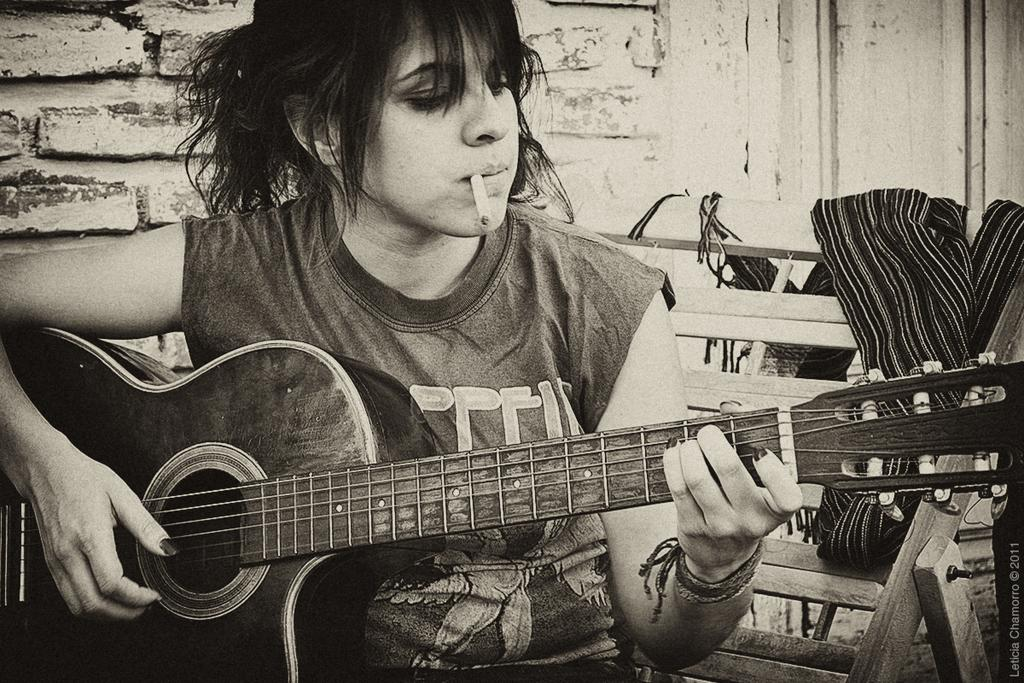Who is the main subject in the image? There is a woman in the image. What is the woman doing in the image? The woman is sitting on a wooden chair and playing a guitar. What is the woman holding in her hand? The woman is smoking a cigarette. What month is it in the image? The month is not mentioned or depicted in the image, so it cannot be determined. 